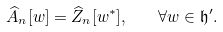Convert formula to latex. <formula><loc_0><loc_0><loc_500><loc_500>\widehat { A } _ { n } [ w ] = \widehat { Z } _ { n } [ w ^ { * } ] , \quad \forall w \in \mathfrak h ^ { \prime } .</formula> 